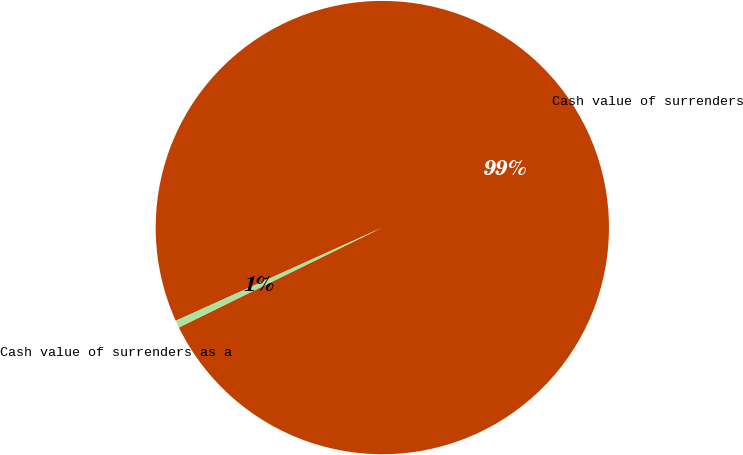Convert chart. <chart><loc_0><loc_0><loc_500><loc_500><pie_chart><fcel>Cash value of surrenders<fcel>Cash value of surrenders as a<nl><fcel>99.48%<fcel>0.52%<nl></chart> 